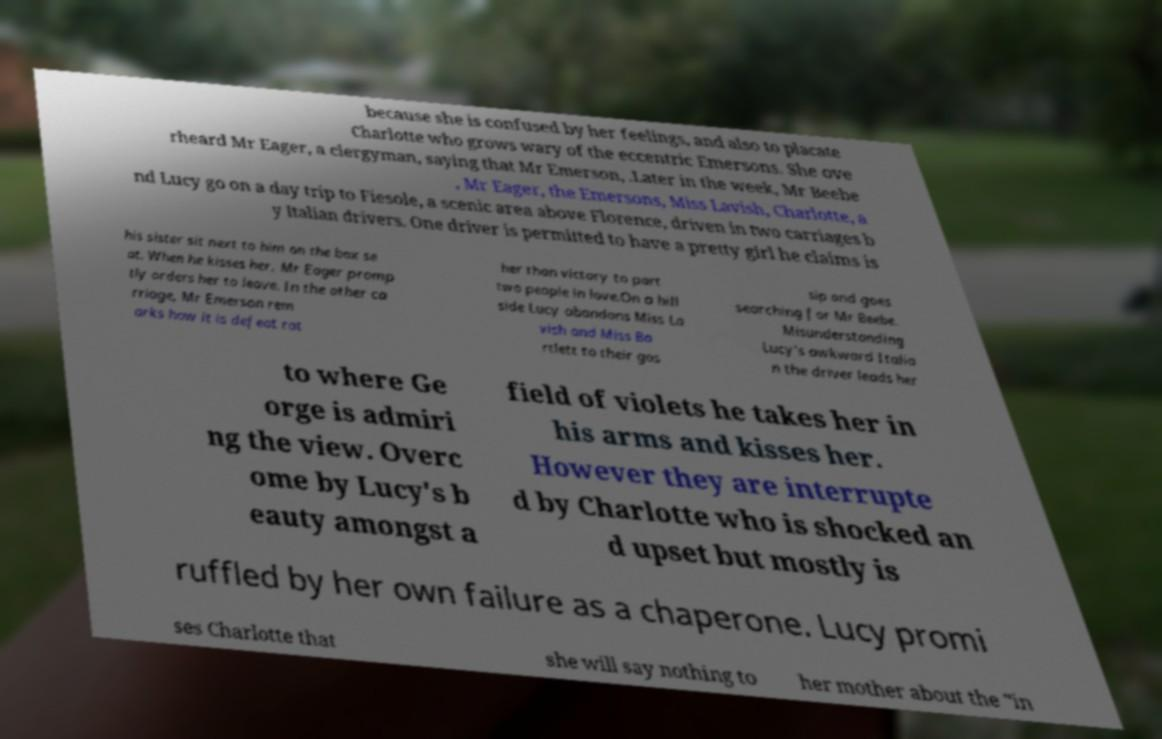I need the written content from this picture converted into text. Can you do that? because she is confused by her feelings, and also to placate Charlotte who grows wary of the eccentric Emersons. She ove rheard Mr Eager, a clergyman, saying that Mr Emerson, .Later in the week, Mr Beebe , Mr Eager, the Emersons, Miss Lavish, Charlotte, a nd Lucy go on a day trip to Fiesole, a scenic area above Florence, driven in two carriages b y Italian drivers. One driver is permitted to have a pretty girl he claims is his sister sit next to him on the box se at. When he kisses her, Mr Eager promp tly orders her to leave. In the other ca rriage, Mr Emerson rem arks how it is defeat rat her than victory to part two people in love.On a hill side Lucy abandons Miss La vish and Miss Ba rtlett to their gos sip and goes searching for Mr Beebe. Misunderstanding Lucy's awkward Italia n the driver leads her to where Ge orge is admiri ng the view. Overc ome by Lucy's b eauty amongst a field of violets he takes her in his arms and kisses her. However they are interrupte d by Charlotte who is shocked an d upset but mostly is ruffled by her own failure as a chaperone. Lucy promi ses Charlotte that she will say nothing to her mother about the "in 